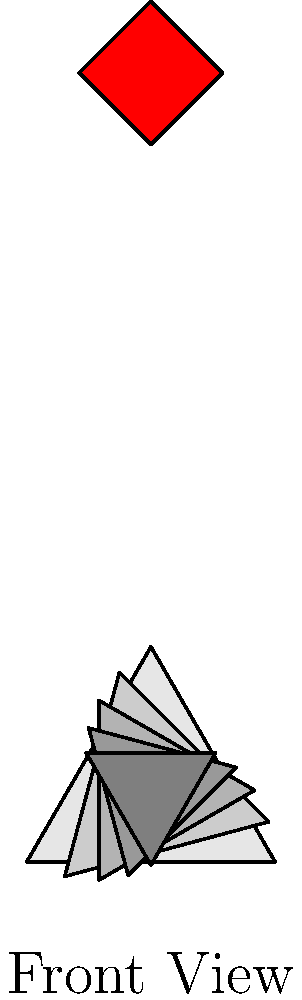The Flame Towers in Baku are known for their distinctive twisted design. If you were to look at a single tower from the front and count the number of visible "twists" (represented by polygon rotations) in the structure, how many would you see based on the given simplified diagram? To solve this problem, we need to analyze the diagram step-by-step:

1. The base of the tower is represented by a triangle (polygon with 3 sides).
2. As we move up the tower, we can see that each level is rotated slightly.
3. The rotation is visible through the change in the orientation of the triangular cross-sections.
4. Starting from the bottom, we can count each distinct rotation:
   - Base level (not counted as a twist)
   - First rotation
   - Second rotation
   - Third rotation
   - Fourth rotation
5. The top flame-like structure is not considered part of the twisting structure.

Therefore, we can count 4 distinct rotations or "twists" in the simplified representation of the Flame Tower.
Answer: 4 twists 